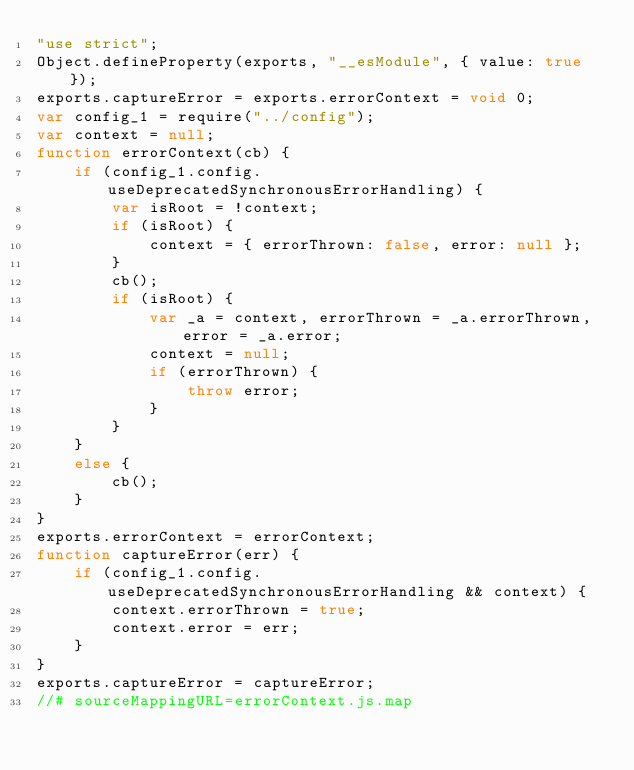<code> <loc_0><loc_0><loc_500><loc_500><_JavaScript_>"use strict";
Object.defineProperty(exports, "__esModule", { value: true });
exports.captureError = exports.errorContext = void 0;
var config_1 = require("../config");
var context = null;
function errorContext(cb) {
    if (config_1.config.useDeprecatedSynchronousErrorHandling) {
        var isRoot = !context;
        if (isRoot) {
            context = { errorThrown: false, error: null };
        }
        cb();
        if (isRoot) {
            var _a = context, errorThrown = _a.errorThrown, error = _a.error;
            context = null;
            if (errorThrown) {
                throw error;
            }
        }
    }
    else {
        cb();
    }
}
exports.errorContext = errorContext;
function captureError(err) {
    if (config_1.config.useDeprecatedSynchronousErrorHandling && context) {
        context.errorThrown = true;
        context.error = err;
    }
}
exports.captureError = captureError;
//# sourceMappingURL=errorContext.js.map</code> 